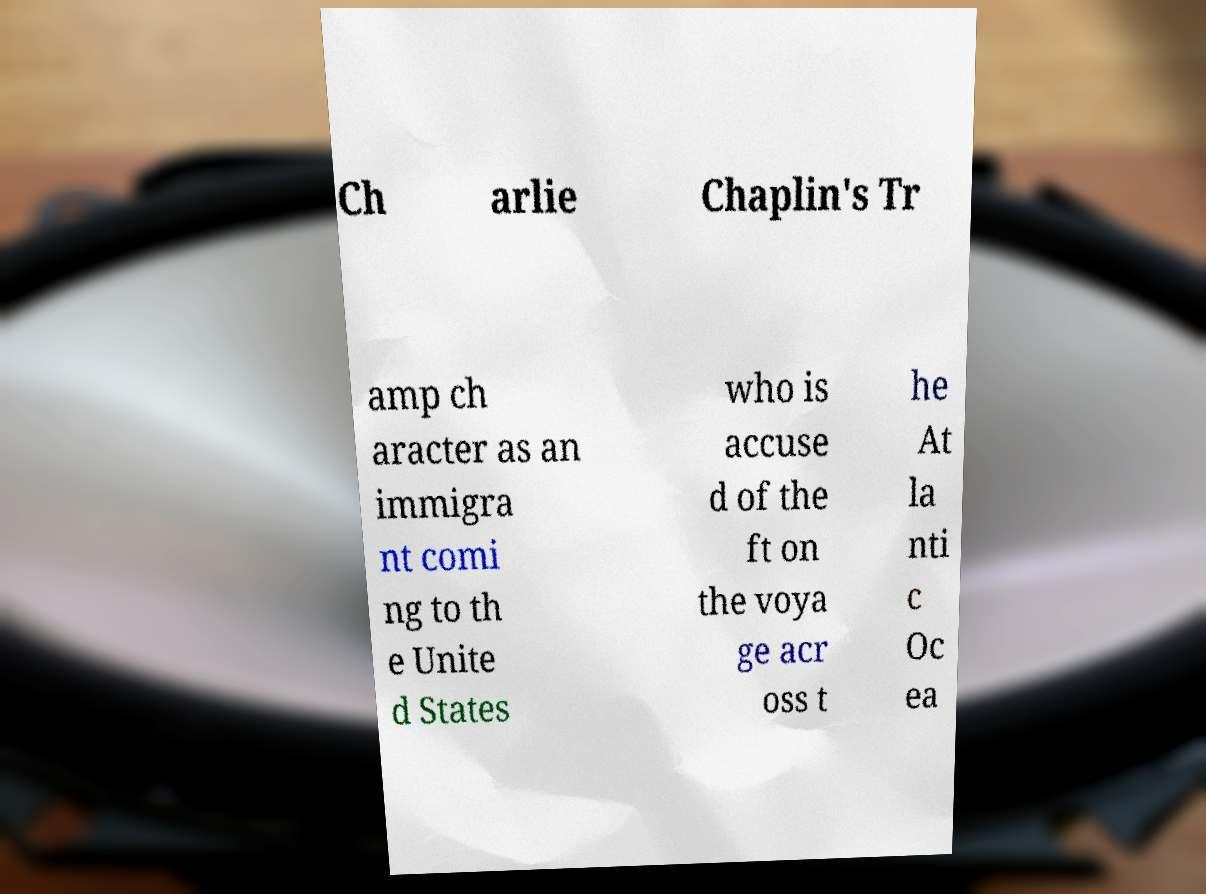Can you accurately transcribe the text from the provided image for me? Ch arlie Chaplin's Tr amp ch aracter as an immigra nt comi ng to th e Unite d States who is accuse d of the ft on the voya ge acr oss t he At la nti c Oc ea 